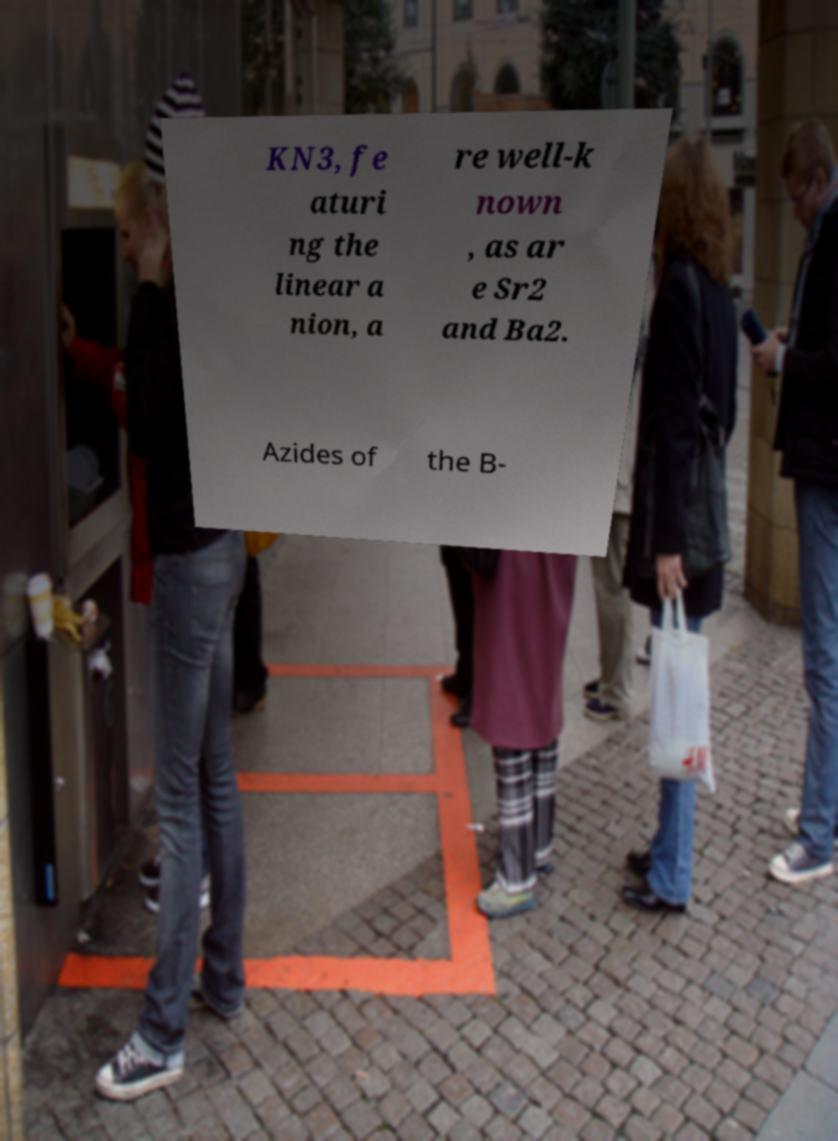Can you accurately transcribe the text from the provided image for me? KN3, fe aturi ng the linear a nion, a re well-k nown , as ar e Sr2 and Ba2. Azides of the B- 